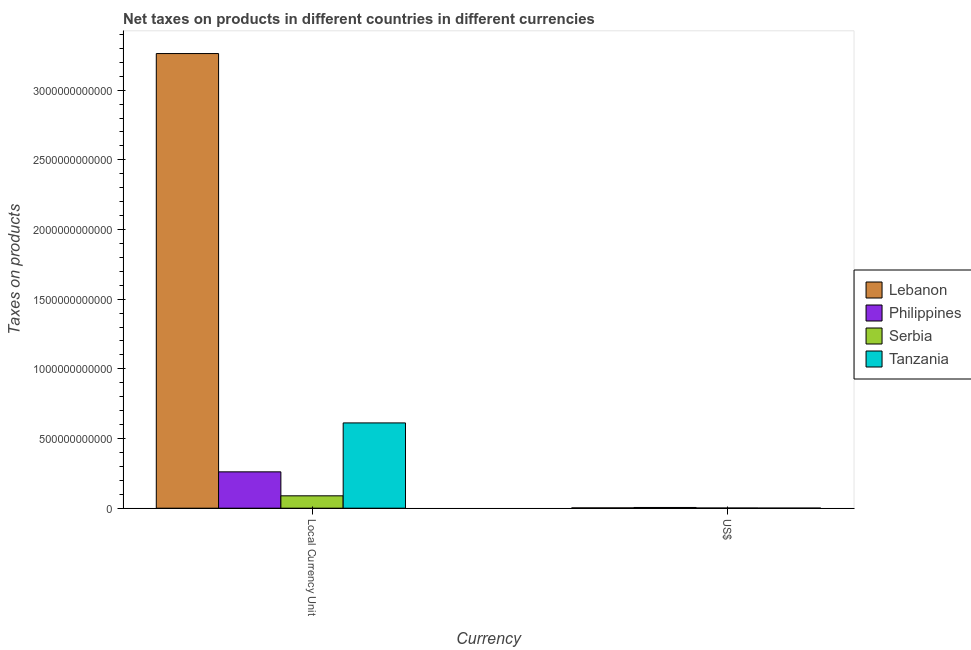How many different coloured bars are there?
Give a very brief answer. 4. How many groups of bars are there?
Your response must be concise. 2. Are the number of bars on each tick of the X-axis equal?
Your answer should be compact. Yes. What is the label of the 2nd group of bars from the left?
Ensure brevity in your answer.  US$. What is the net taxes in us$ in Lebanon?
Provide a short and direct response. 2.16e+09. Across all countries, what is the maximum net taxes in us$?
Your answer should be compact. 5.11e+09. Across all countries, what is the minimum net taxes in constant 2005 us$?
Give a very brief answer. 8.88e+1. In which country was the net taxes in constant 2005 us$ maximum?
Make the answer very short. Lebanon. In which country was the net taxes in constant 2005 us$ minimum?
Keep it short and to the point. Serbia. What is the total net taxes in constant 2005 us$ in the graph?
Your answer should be compact. 4.22e+12. What is the difference between the net taxes in us$ in Lebanon and that in Tanzania?
Ensure brevity in your answer.  1.47e+09. What is the difference between the net taxes in constant 2005 us$ in Lebanon and the net taxes in us$ in Philippines?
Your response must be concise. 3.26e+12. What is the average net taxes in us$ per country?
Keep it short and to the point. 2.33e+09. What is the difference between the net taxes in constant 2005 us$ and net taxes in us$ in Serbia?
Make the answer very short. 8.75e+1. What is the ratio of the net taxes in constant 2005 us$ in Serbia to that in Philippines?
Your answer should be compact. 0.34. Is the net taxes in constant 2005 us$ in Tanzania less than that in Philippines?
Your answer should be compact. No. In how many countries, is the net taxes in us$ greater than the average net taxes in us$ taken over all countries?
Ensure brevity in your answer.  1. What does the 2nd bar from the left in Local Currency Unit represents?
Provide a succinct answer. Philippines. What does the 1st bar from the right in US$ represents?
Provide a short and direct response. Tanzania. How many bars are there?
Provide a short and direct response. 8. What is the difference between two consecutive major ticks on the Y-axis?
Offer a terse response. 5.00e+11. Are the values on the major ticks of Y-axis written in scientific E-notation?
Make the answer very short. No. Does the graph contain any zero values?
Make the answer very short. No. How are the legend labels stacked?
Offer a very short reply. Vertical. What is the title of the graph?
Ensure brevity in your answer.  Net taxes on products in different countries in different currencies. Does "South Africa" appear as one of the legend labels in the graph?
Ensure brevity in your answer.  No. What is the label or title of the X-axis?
Provide a short and direct response. Currency. What is the label or title of the Y-axis?
Offer a terse response. Taxes on products. What is the Taxes on products in Lebanon in Local Currency Unit?
Ensure brevity in your answer.  3.26e+12. What is the Taxes on products of Philippines in Local Currency Unit?
Offer a terse response. 2.61e+11. What is the Taxes on products in Serbia in Local Currency Unit?
Your response must be concise. 8.88e+1. What is the Taxes on products in Tanzania in Local Currency Unit?
Your answer should be very brief. 6.12e+11. What is the Taxes on products in Lebanon in US$?
Provide a short and direct response. 2.16e+09. What is the Taxes on products of Philippines in US$?
Your answer should be very brief. 5.11e+09. What is the Taxes on products of Serbia in US$?
Your response must be concise. 1.33e+09. What is the Taxes on products of Tanzania in US$?
Your answer should be very brief. 6.98e+08. Across all Currency, what is the maximum Taxes on products of Lebanon?
Keep it short and to the point. 3.26e+12. Across all Currency, what is the maximum Taxes on products of Philippines?
Offer a terse response. 2.61e+11. Across all Currency, what is the maximum Taxes on products in Serbia?
Make the answer very short. 8.88e+1. Across all Currency, what is the maximum Taxes on products in Tanzania?
Your answer should be compact. 6.12e+11. Across all Currency, what is the minimum Taxes on products in Lebanon?
Ensure brevity in your answer.  2.16e+09. Across all Currency, what is the minimum Taxes on products in Philippines?
Your answer should be very brief. 5.11e+09. Across all Currency, what is the minimum Taxes on products in Serbia?
Offer a very short reply. 1.33e+09. Across all Currency, what is the minimum Taxes on products of Tanzania?
Your response must be concise. 6.98e+08. What is the total Taxes on products of Lebanon in the graph?
Give a very brief answer. 3.27e+12. What is the total Taxes on products in Philippines in the graph?
Offer a terse response. 2.66e+11. What is the total Taxes on products of Serbia in the graph?
Your response must be concise. 9.01e+1. What is the total Taxes on products in Tanzania in the graph?
Your response must be concise. 6.13e+11. What is the difference between the Taxes on products in Lebanon in Local Currency Unit and that in US$?
Provide a succinct answer. 3.26e+12. What is the difference between the Taxes on products of Philippines in Local Currency Unit and that in US$?
Provide a succinct answer. 2.56e+11. What is the difference between the Taxes on products in Serbia in Local Currency Unit and that in US$?
Provide a succinct answer. 8.75e+1. What is the difference between the Taxes on products in Tanzania in Local Currency Unit and that in US$?
Offer a very short reply. 6.11e+11. What is the difference between the Taxes on products in Lebanon in Local Currency Unit and the Taxes on products in Philippines in US$?
Your answer should be very brief. 3.26e+12. What is the difference between the Taxes on products of Lebanon in Local Currency Unit and the Taxes on products of Serbia in US$?
Your answer should be very brief. 3.26e+12. What is the difference between the Taxes on products in Lebanon in Local Currency Unit and the Taxes on products in Tanzania in US$?
Ensure brevity in your answer.  3.26e+12. What is the difference between the Taxes on products in Philippines in Local Currency Unit and the Taxes on products in Serbia in US$?
Keep it short and to the point. 2.59e+11. What is the difference between the Taxes on products in Philippines in Local Currency Unit and the Taxes on products in Tanzania in US$?
Keep it short and to the point. 2.60e+11. What is the difference between the Taxes on products in Serbia in Local Currency Unit and the Taxes on products in Tanzania in US$?
Provide a short and direct response. 8.81e+1. What is the average Taxes on products of Lebanon per Currency?
Offer a very short reply. 1.63e+12. What is the average Taxes on products of Philippines per Currency?
Offer a terse response. 1.33e+11. What is the average Taxes on products in Serbia per Currency?
Offer a very short reply. 4.51e+1. What is the average Taxes on products in Tanzania per Currency?
Make the answer very short. 3.06e+11. What is the difference between the Taxes on products of Lebanon and Taxes on products of Philippines in Local Currency Unit?
Your answer should be compact. 3.00e+12. What is the difference between the Taxes on products in Lebanon and Taxes on products in Serbia in Local Currency Unit?
Your response must be concise. 3.17e+12. What is the difference between the Taxes on products in Lebanon and Taxes on products in Tanzania in Local Currency Unit?
Ensure brevity in your answer.  2.65e+12. What is the difference between the Taxes on products in Philippines and Taxes on products in Serbia in Local Currency Unit?
Offer a terse response. 1.72e+11. What is the difference between the Taxes on products of Philippines and Taxes on products of Tanzania in Local Currency Unit?
Make the answer very short. -3.51e+11. What is the difference between the Taxes on products of Serbia and Taxes on products of Tanzania in Local Currency Unit?
Give a very brief answer. -5.23e+11. What is the difference between the Taxes on products in Lebanon and Taxes on products in Philippines in US$?
Your answer should be compact. -2.95e+09. What is the difference between the Taxes on products in Lebanon and Taxes on products in Serbia in US$?
Your answer should be compact. 8.37e+08. What is the difference between the Taxes on products in Lebanon and Taxes on products in Tanzania in US$?
Offer a very short reply. 1.47e+09. What is the difference between the Taxes on products of Philippines and Taxes on products of Serbia in US$?
Your answer should be very brief. 3.79e+09. What is the difference between the Taxes on products in Philippines and Taxes on products in Tanzania in US$?
Make the answer very short. 4.42e+09. What is the difference between the Taxes on products of Serbia and Taxes on products of Tanzania in US$?
Keep it short and to the point. 6.29e+08. What is the ratio of the Taxes on products of Lebanon in Local Currency Unit to that in US$?
Ensure brevity in your answer.  1507.5. What is the ratio of the Taxes on products of Philippines in Local Currency Unit to that in US$?
Offer a very short reply. 50.99. What is the ratio of the Taxes on products in Serbia in Local Currency Unit to that in US$?
Keep it short and to the point. 66.91. What is the ratio of the Taxes on products in Tanzania in Local Currency Unit to that in US$?
Your answer should be very brief. 876.41. What is the difference between the highest and the second highest Taxes on products of Lebanon?
Give a very brief answer. 3.26e+12. What is the difference between the highest and the second highest Taxes on products in Philippines?
Offer a terse response. 2.56e+11. What is the difference between the highest and the second highest Taxes on products in Serbia?
Offer a terse response. 8.75e+1. What is the difference between the highest and the second highest Taxes on products in Tanzania?
Offer a terse response. 6.11e+11. What is the difference between the highest and the lowest Taxes on products of Lebanon?
Offer a very short reply. 3.26e+12. What is the difference between the highest and the lowest Taxes on products in Philippines?
Keep it short and to the point. 2.56e+11. What is the difference between the highest and the lowest Taxes on products of Serbia?
Provide a short and direct response. 8.75e+1. What is the difference between the highest and the lowest Taxes on products of Tanzania?
Make the answer very short. 6.11e+11. 